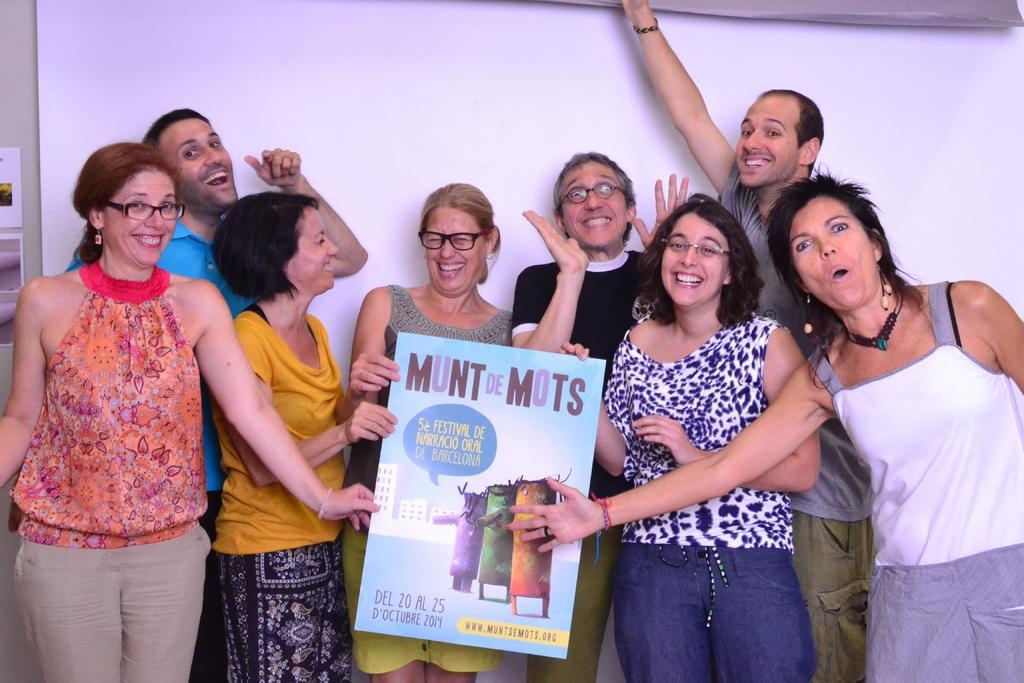In one or two sentences, can you explain what this image depicts? In this image, we can see people wearing clothes. There is a board at the bottom of the image. 